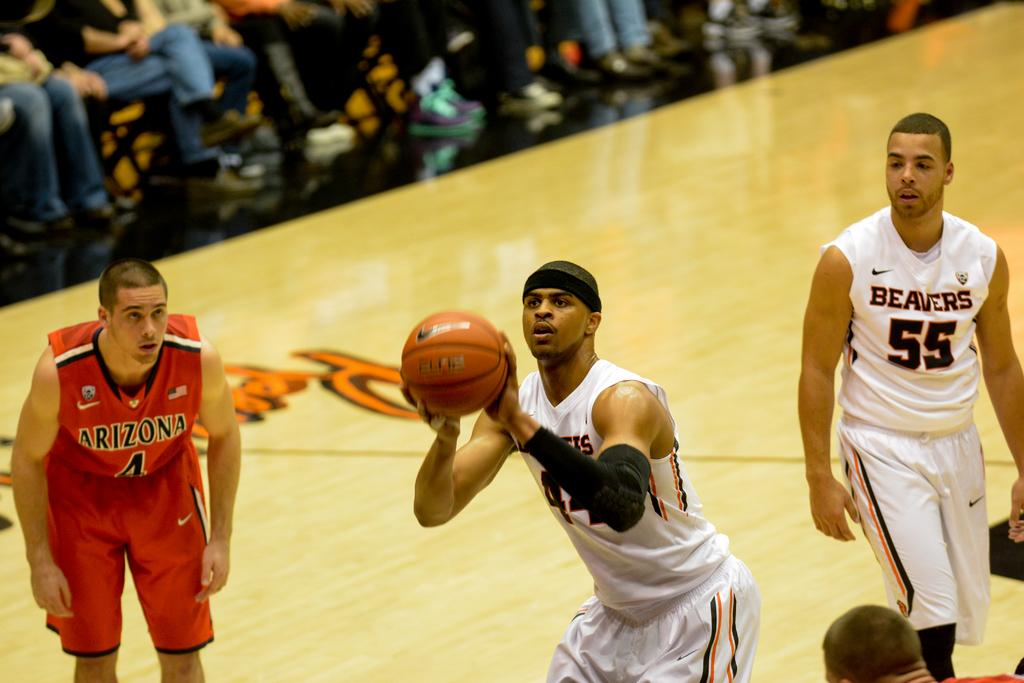<image>
Share a concise interpretation of the image provided. men from the beaver and arizona playing a game of basetball 